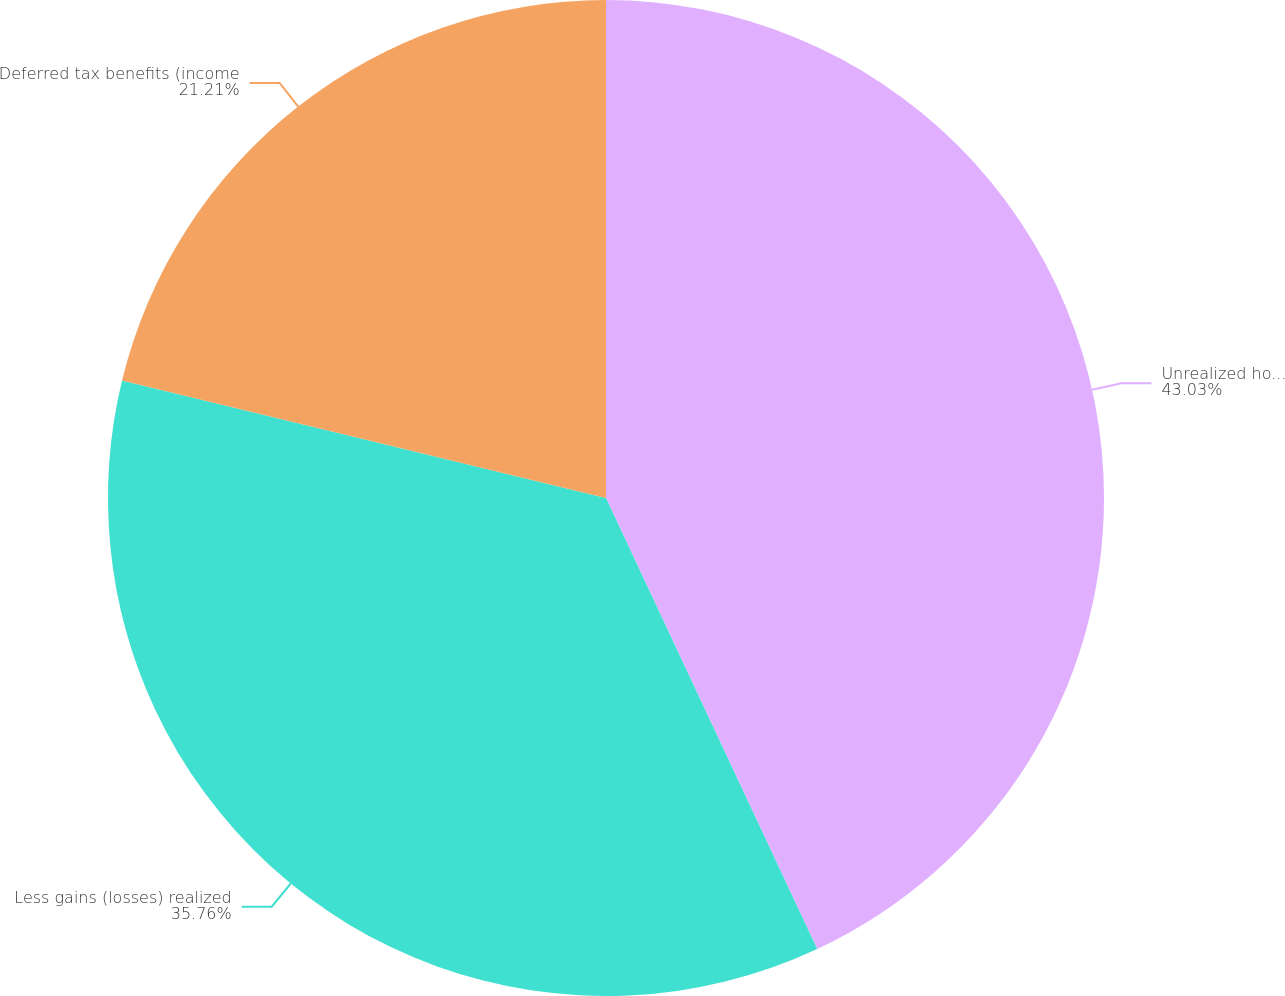Convert chart. <chart><loc_0><loc_0><loc_500><loc_500><pie_chart><fcel>Unrealized holding gains<fcel>Less gains (losses) realized<fcel>Deferred tax benefits (income<nl><fcel>43.03%<fcel>35.76%<fcel>21.21%<nl></chart> 